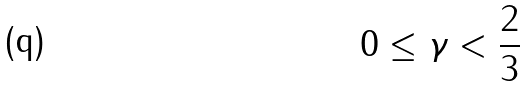<formula> <loc_0><loc_0><loc_500><loc_500>0 \leq \gamma < \frac { 2 } { 3 }</formula> 